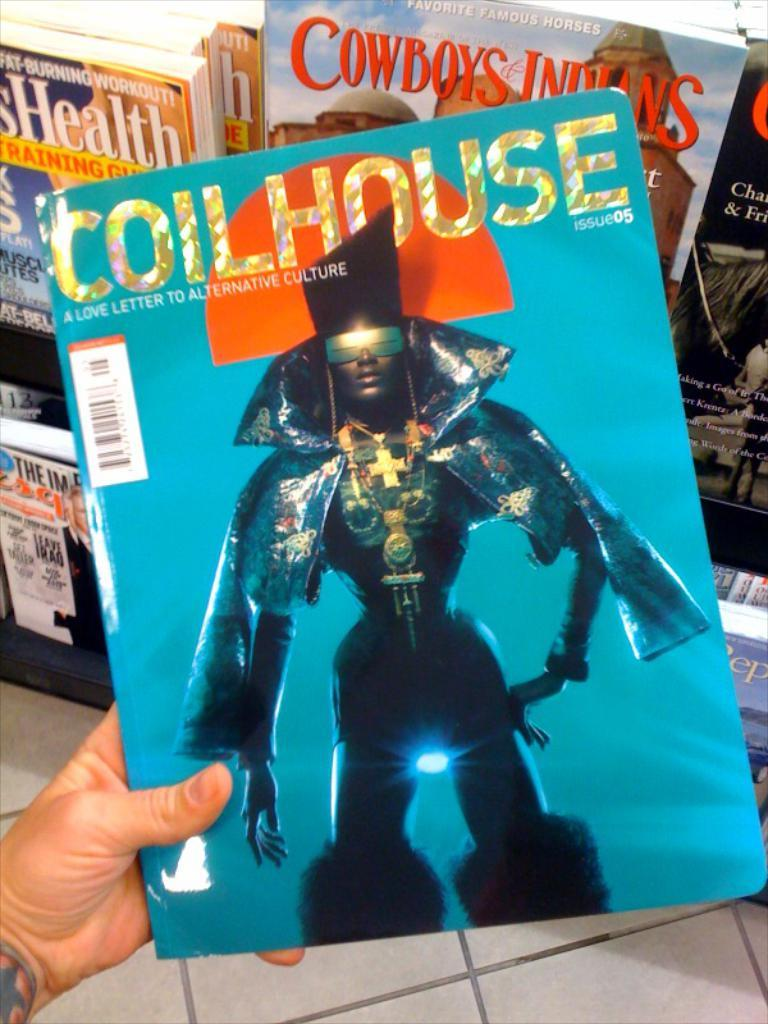What is the person's hand holding in the image? There is a person's hand holding a book in the image. Are there any other books visible in the image? Yes, there are books on a stand in the image. What can be seen beneath the books and the person's hand? The floor is visible in the image. What type of iron is being used to make a decision in the image? There is no iron or decision-making process depicted in the image; it only shows a person's hand holding a book and books on a stand. 